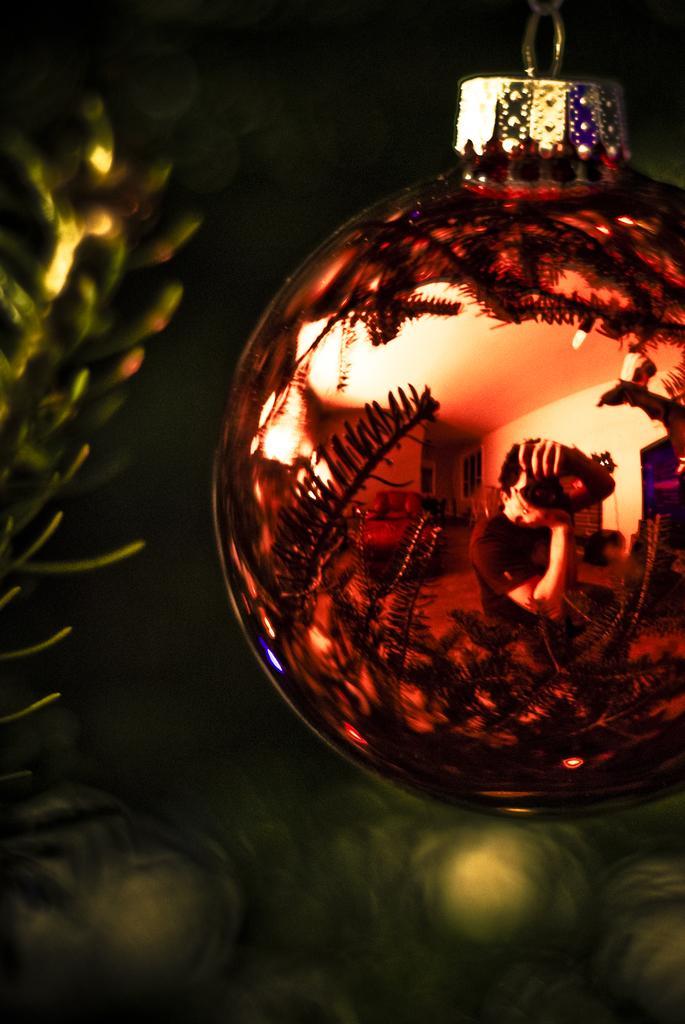How would you summarize this image in a sentence or two? In this image there is a Christmas ornament in the middle. On the left side there is a Christmas tree with the light. It seems like it is a red ball in which we can see the reflections. 